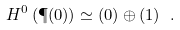<formula> <loc_0><loc_0><loc_500><loc_500>H ^ { 0 } \left ( \P ( 0 ) \right ) \simeq \L ( 0 ) \oplus \L ( 1 ) \ .</formula> 